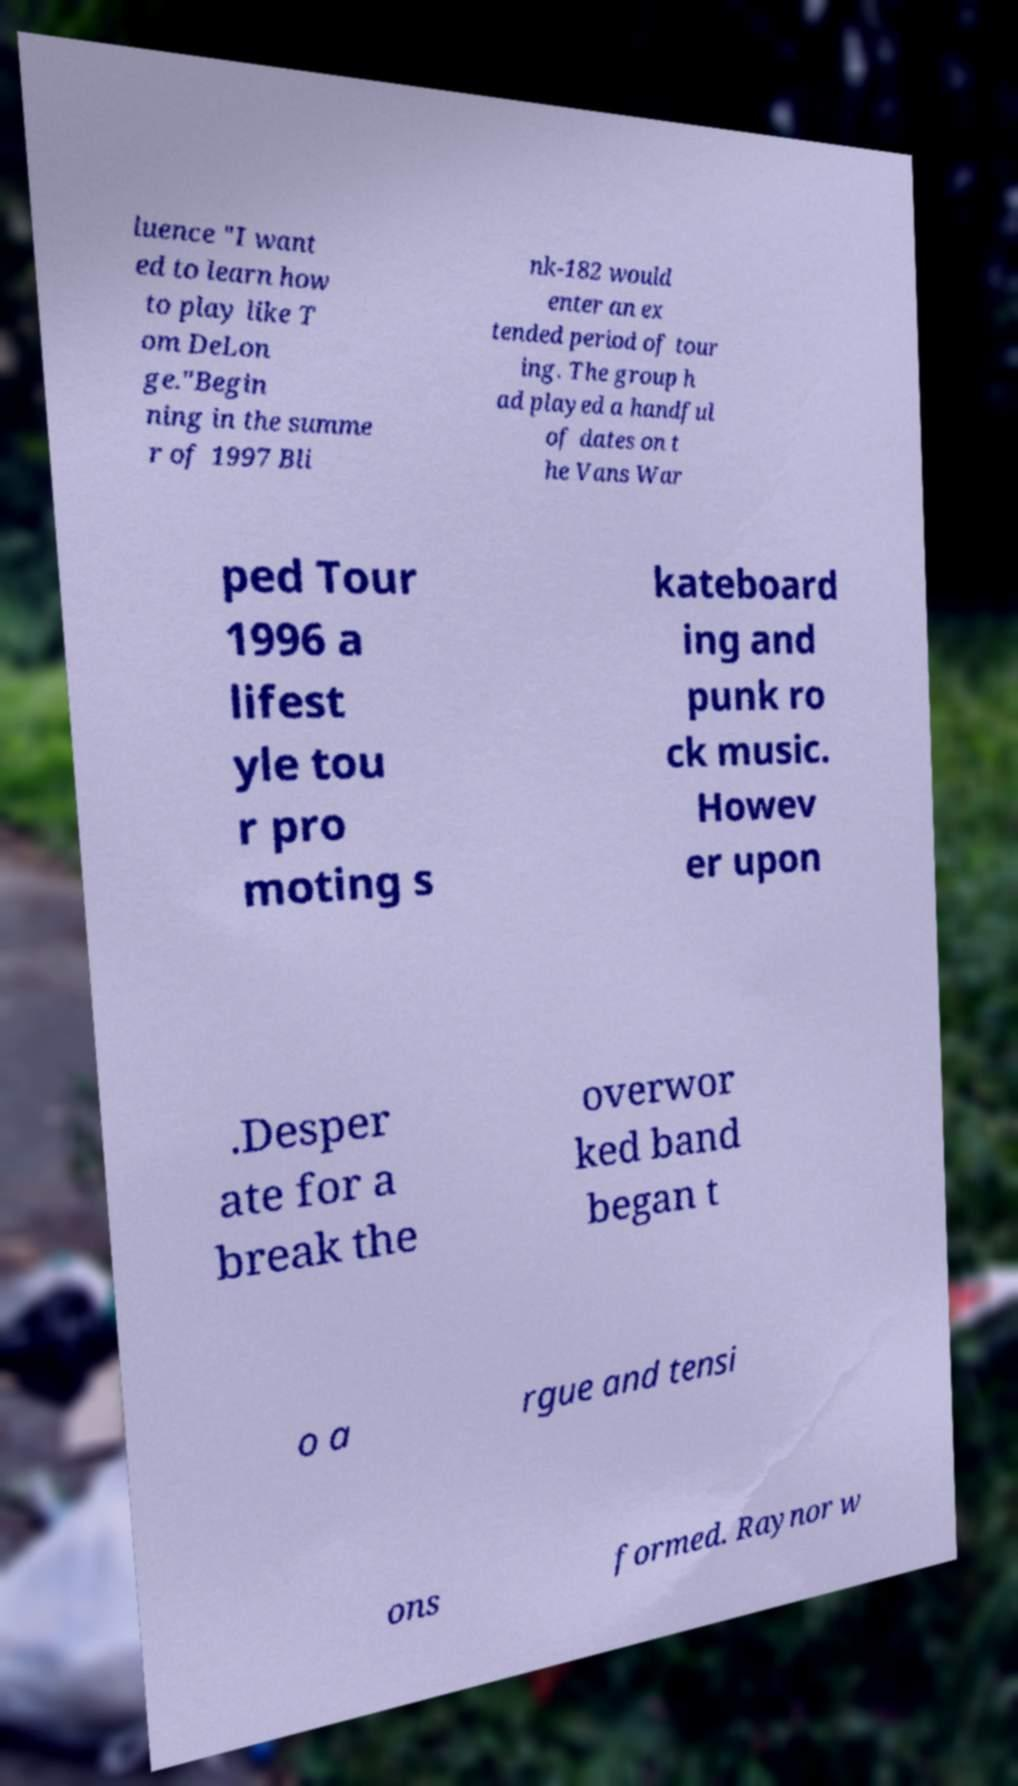I need the written content from this picture converted into text. Can you do that? luence "I want ed to learn how to play like T om DeLon ge."Begin ning in the summe r of 1997 Bli nk-182 would enter an ex tended period of tour ing. The group h ad played a handful of dates on t he Vans War ped Tour 1996 a lifest yle tou r pro moting s kateboard ing and punk ro ck music. Howev er upon .Desper ate for a break the overwor ked band began t o a rgue and tensi ons formed. Raynor w 